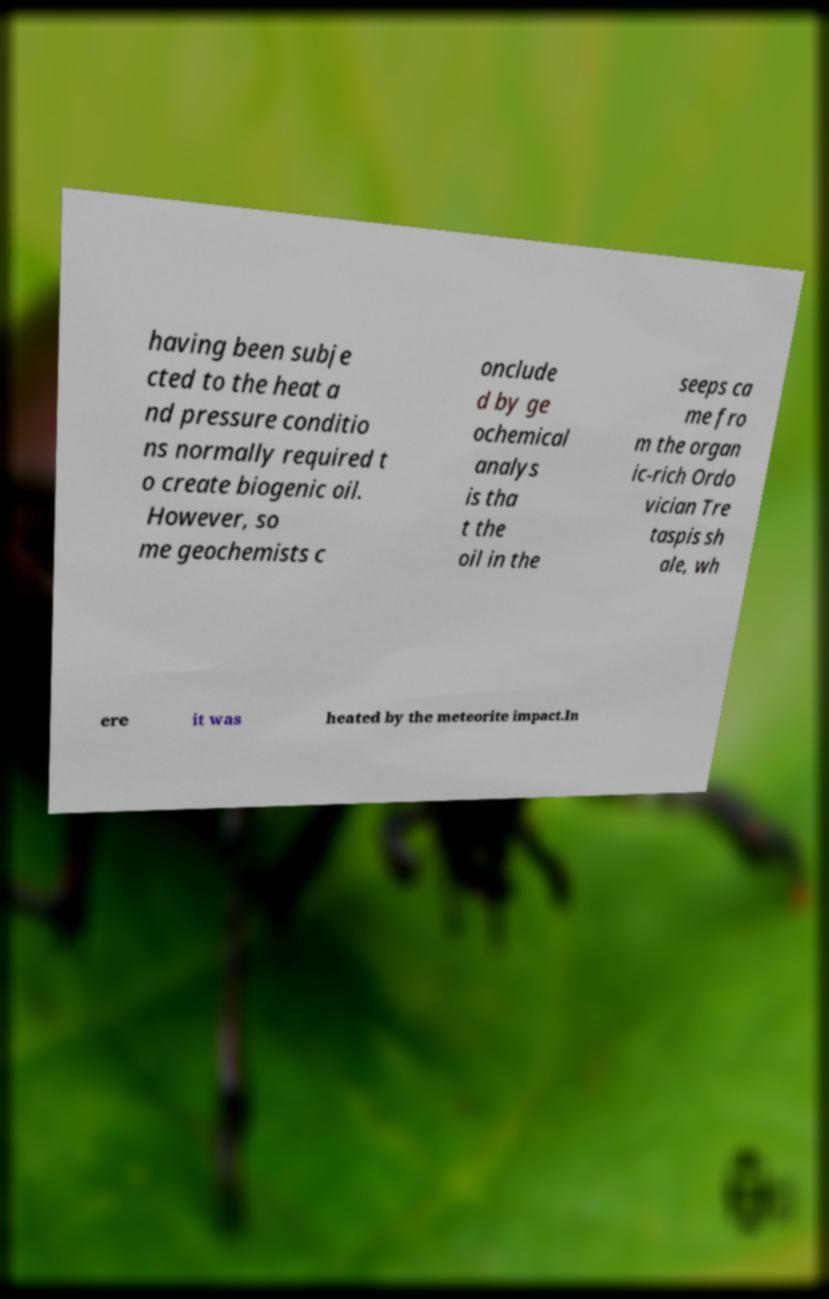Can you accurately transcribe the text from the provided image for me? having been subje cted to the heat a nd pressure conditio ns normally required t o create biogenic oil. However, so me geochemists c onclude d by ge ochemical analys is tha t the oil in the seeps ca me fro m the organ ic-rich Ordo vician Tre taspis sh ale, wh ere it was heated by the meteorite impact.In 